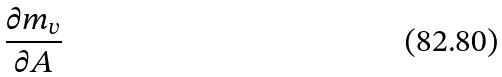<formula> <loc_0><loc_0><loc_500><loc_500>\frac { \partial m _ { v } } { \partial A }</formula> 